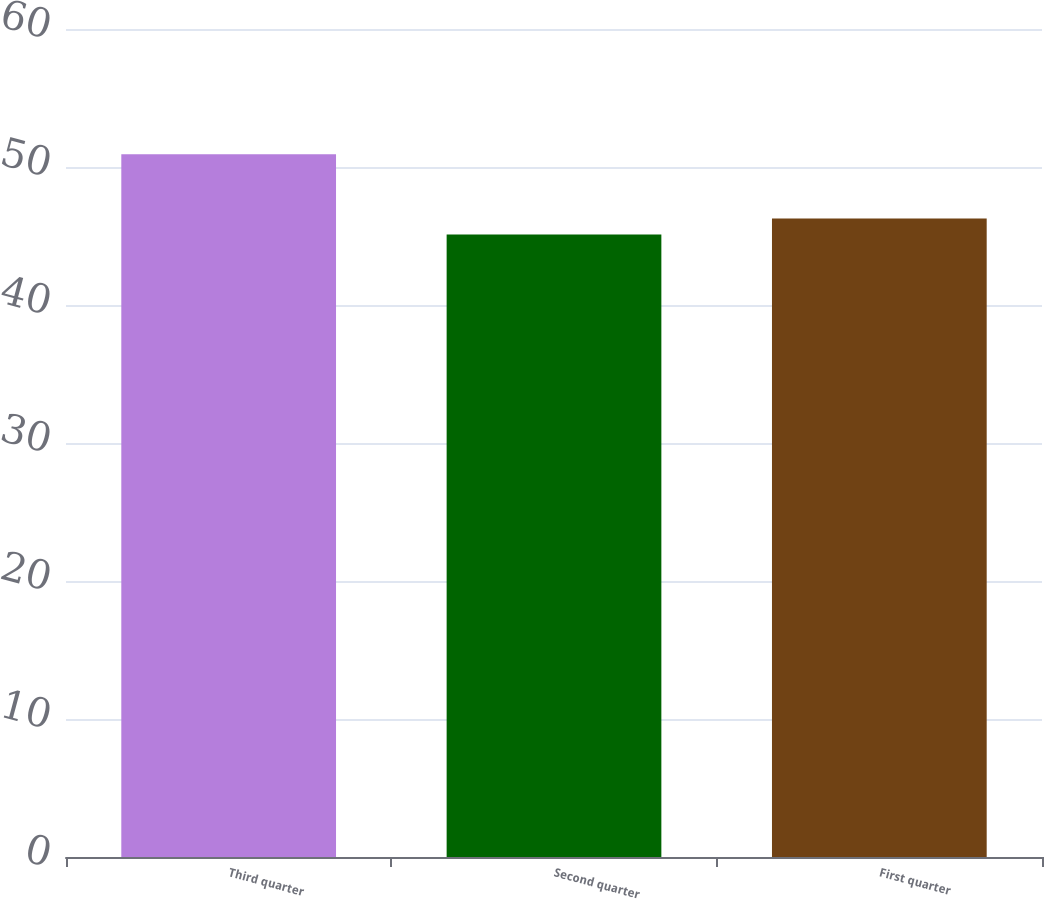Convert chart to OTSL. <chart><loc_0><loc_0><loc_500><loc_500><bar_chart><fcel>Third quarter<fcel>Second quarter<fcel>First quarter<nl><fcel>50.93<fcel>45.11<fcel>46.27<nl></chart> 